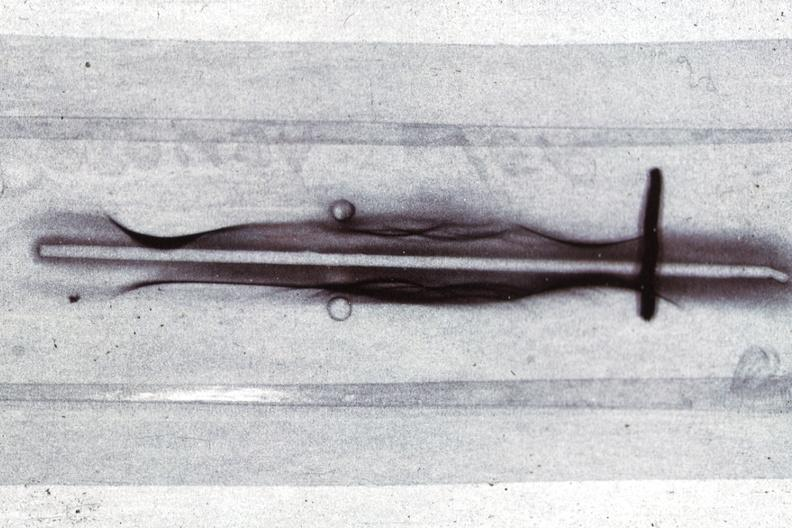what does this image show?
Answer the question using a single word or phrase. Immunoelectrophoresis showing monoclonal band which is an igg case of multiple myeloma 